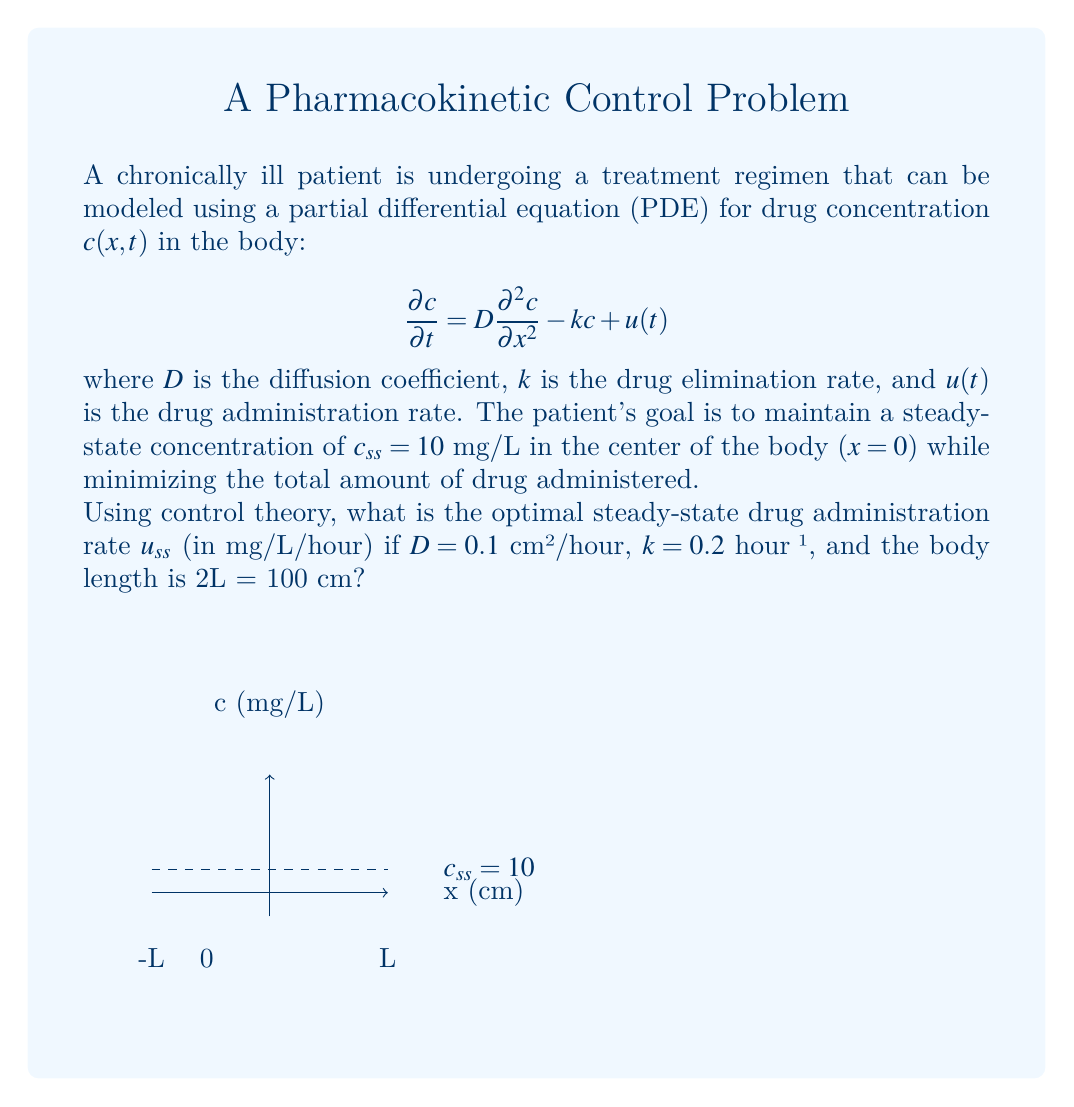Help me with this question. To solve this problem, we'll follow these steps:

1) In steady-state, the time derivative is zero, so our PDE becomes an ODE:

   $$0 = D\frac{d^2 c}{dx^2} - kc + u_{ss}$$

2) The general solution to this ODE is:

   $$c(x) = A\exp(\sqrt{\frac{k}{D}}x) + B\exp(-\sqrt{\frac{k}{D}}x) + \frac{u_{ss}}{k}$$

3) We have symmetry around x=0, so A=B. Let's call this constant C:

   $$c(x) = C[\exp(\sqrt{\frac{k}{D}}x) + \exp(-\sqrt{\frac{k}{D}}x)] + \frac{u_{ss}}{k}$$

4) At x=0, we want c=10:

   $$10 = 2C + \frac{u_{ss}}{k}$$

5) At x=L (edge of the body), we assume the concentration is zero:

   $$0 = C[\exp(\sqrt{\frac{k}{D}}L) + \exp(-\sqrt{\frac{k}{D}}L)] + \frac{u_{ss}}{k}$$

6) From steps 4 and 5, we can solve for C:

   $$C = \frac{5k - \frac{u_{ss}}{2}}{k[\exp(\sqrt{\frac{k}{D}}L) + \exp(-\sqrt{\frac{k}{D}}L) - 2]}$$

7) Substituting the given values:

   $$L = 50\text{ cm}, D = 0.1\text{ cm²/hour}, k = 0.2\text{ hour}^{-1}$$

   $$C = \frac{1 - \frac{u_{ss}}{2}}{0.2[\exp(\sqrt{2}50) + \exp(-\sqrt{2}50) - 2]}$$

8) For this to be true, the numerator must be zero (as the denominator is very large):

   $$1 - \frac{u_{ss}}{2} = 0$$

9) Solving for $u_{ss}$:

   $$u_{ss} = 2\text{ mg/L/hour}$$

This is the optimal steady-state drug administration rate.
Answer: $u_{ss} = 2$ mg/L/hour 